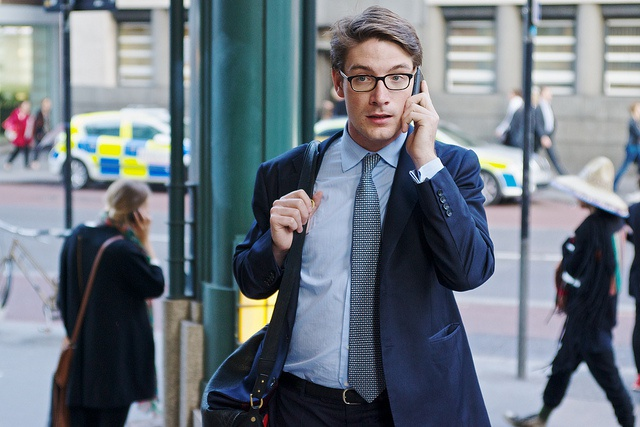Describe the objects in this image and their specific colors. I can see people in darkgray, black, and navy tones, people in darkgray, black, maroon, and gray tones, people in darkgray, black, and lightgray tones, car in darkgray, lightgray, khaki, and lightblue tones, and handbag in darkgray, black, navy, and blue tones in this image. 